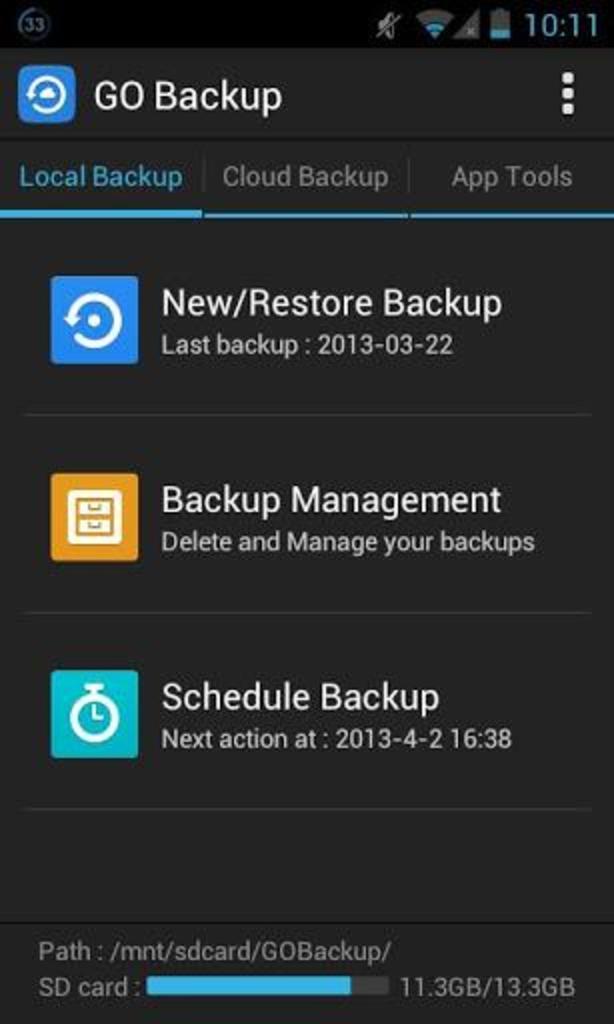Can you describe this image briefly? In this image there is a screenshot of mobile settings. 